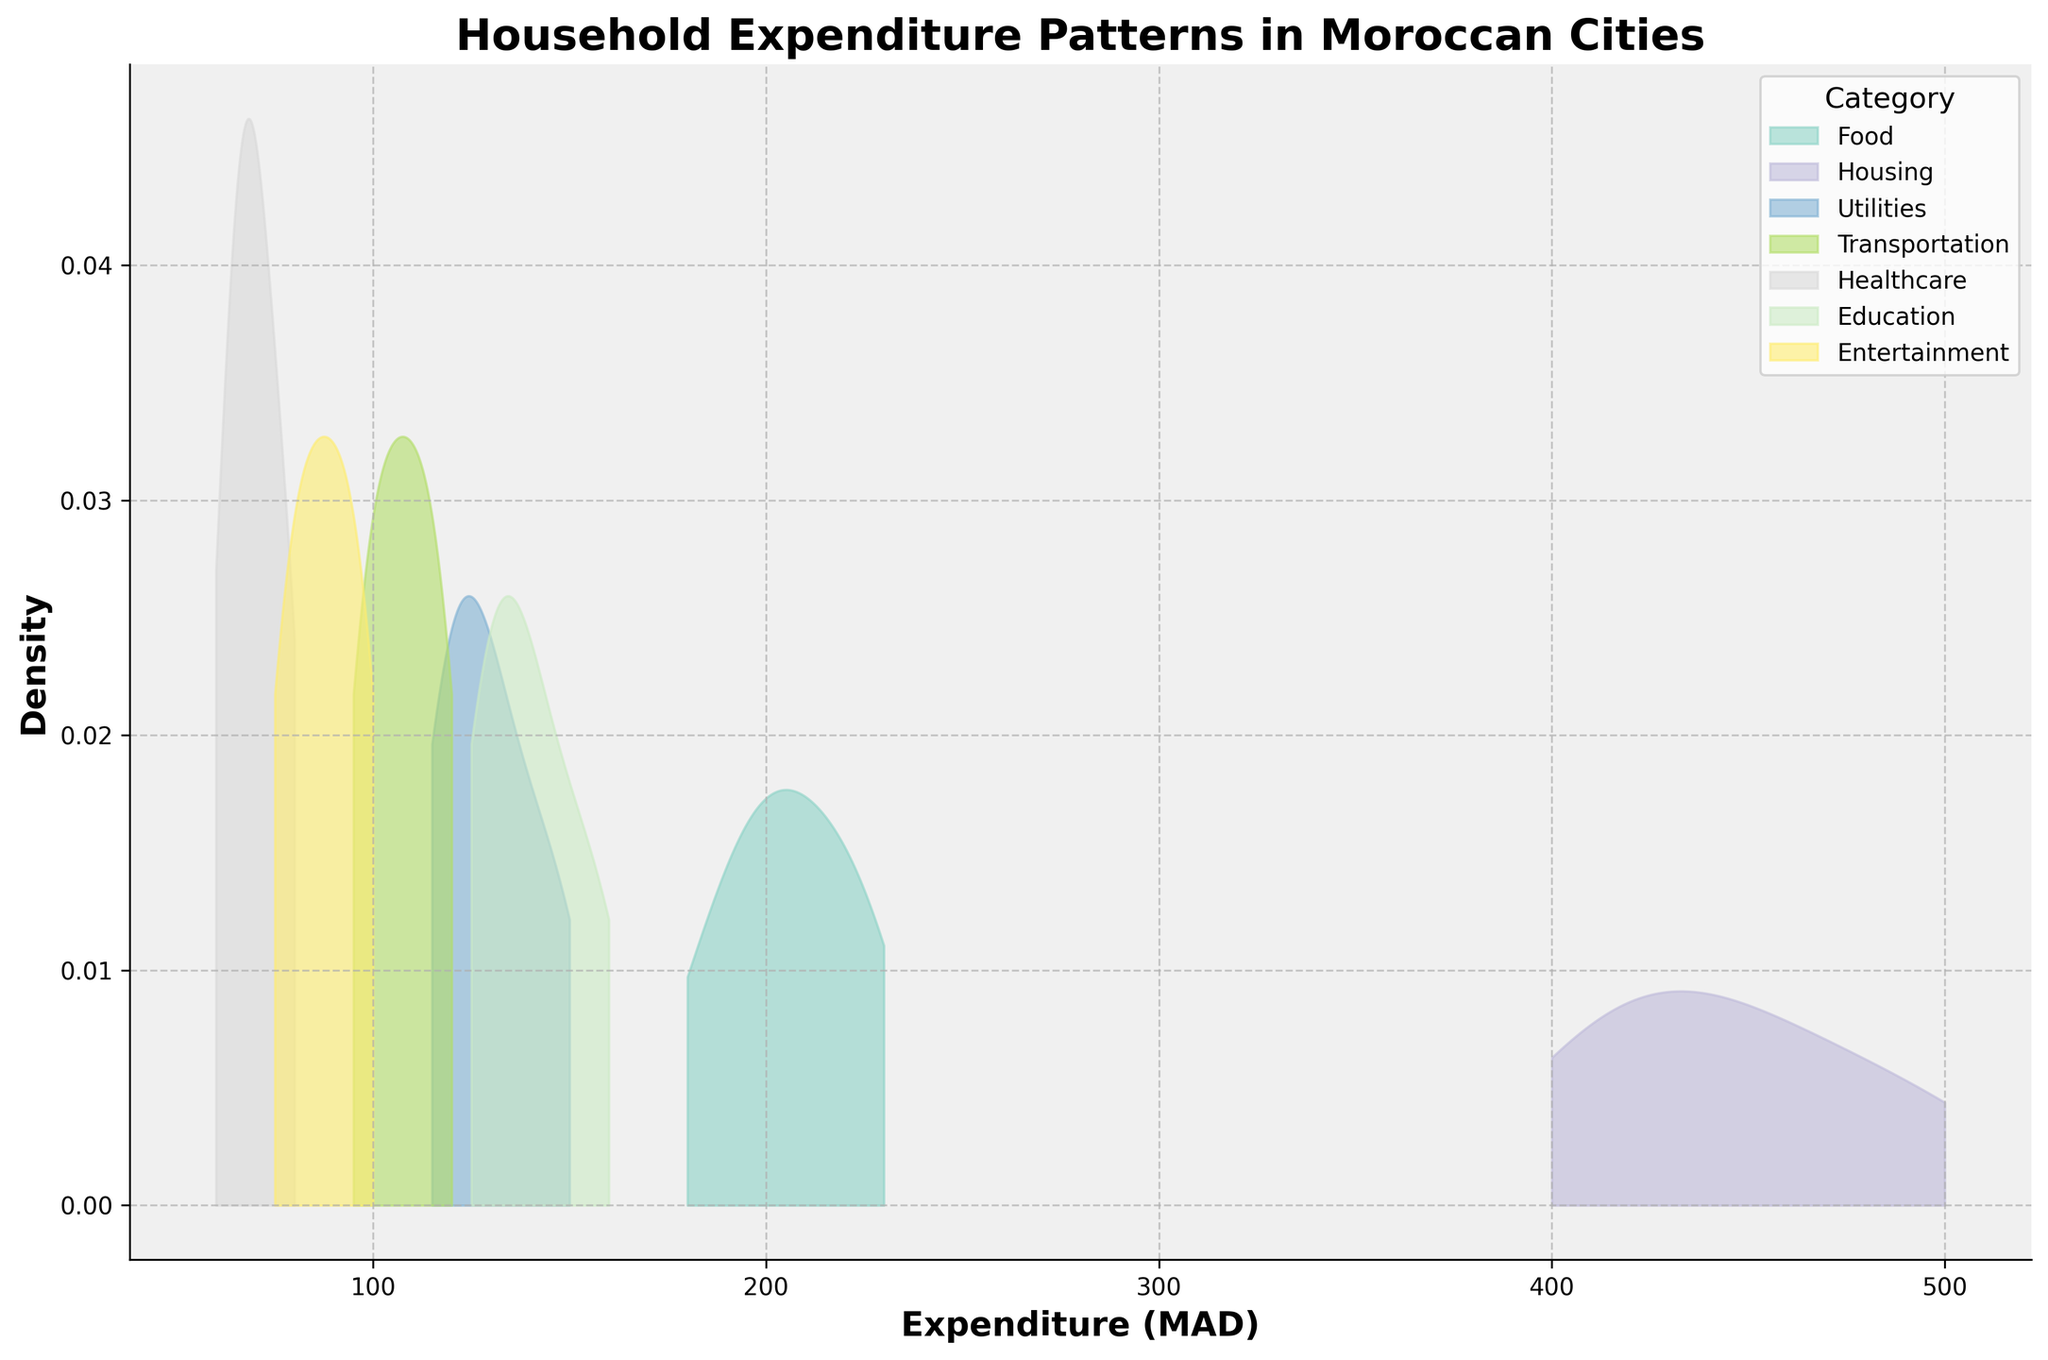What is the title of the plot? The title can be found at the top of the plot.
Answer: Household Expenditure Patterns in Moroccan Cities Which category has the highest expenditure in Casablanca? By observing the density peaks, identify the category with the largest expenditure in Casablanca.
Answer: Housing What is the lowest expenditure for Utilities across all cities? Look for the minimum value along the x-axis for the Utilities category.
Answer: 115 Which category has the wider range of expenditures? Compare the spans of the different density curves along the x-axis. The wider the span, the wider the range.
Answer: Housing Do food expenditures in Rabat appear higher or lower than in Fez based on density? Compare the peaks and spread of the Food density curves between Rabat and Fez along the x-axis.
Answer: Higher How do the density curves for Transportation and Healthcare compare in terms of spread? Observe the x-axis range covered by the density curves of both categories. The one with the larger range is more spread out.
Answer: Transportation is more spread out than Healthcare For which category is the median expenditure closest to 100 MAD? Identify where the peak of the density curve centers around 100 MAD along the x-axis.
Answer: Entertainment Is the density for the Education category more concentrated or spread out? Look for the shape of the Education density curve. A taller, narrower shape indicates more concentration, while a wider shape indicates it being spread out.
Answer: More concentrated Which category shows the smallest expenditure variation in Tangier? Examine the density curves for the Tangier data, noting which one has the narrowest spread indicating less variation.
Answer: Healthcare Between Marrakesh and Agadir, which city spends more on Entertainment based on the density insights? Compare the peaks and the density spread of the Entertainment category for both cities.
Answer: Marrakesh 